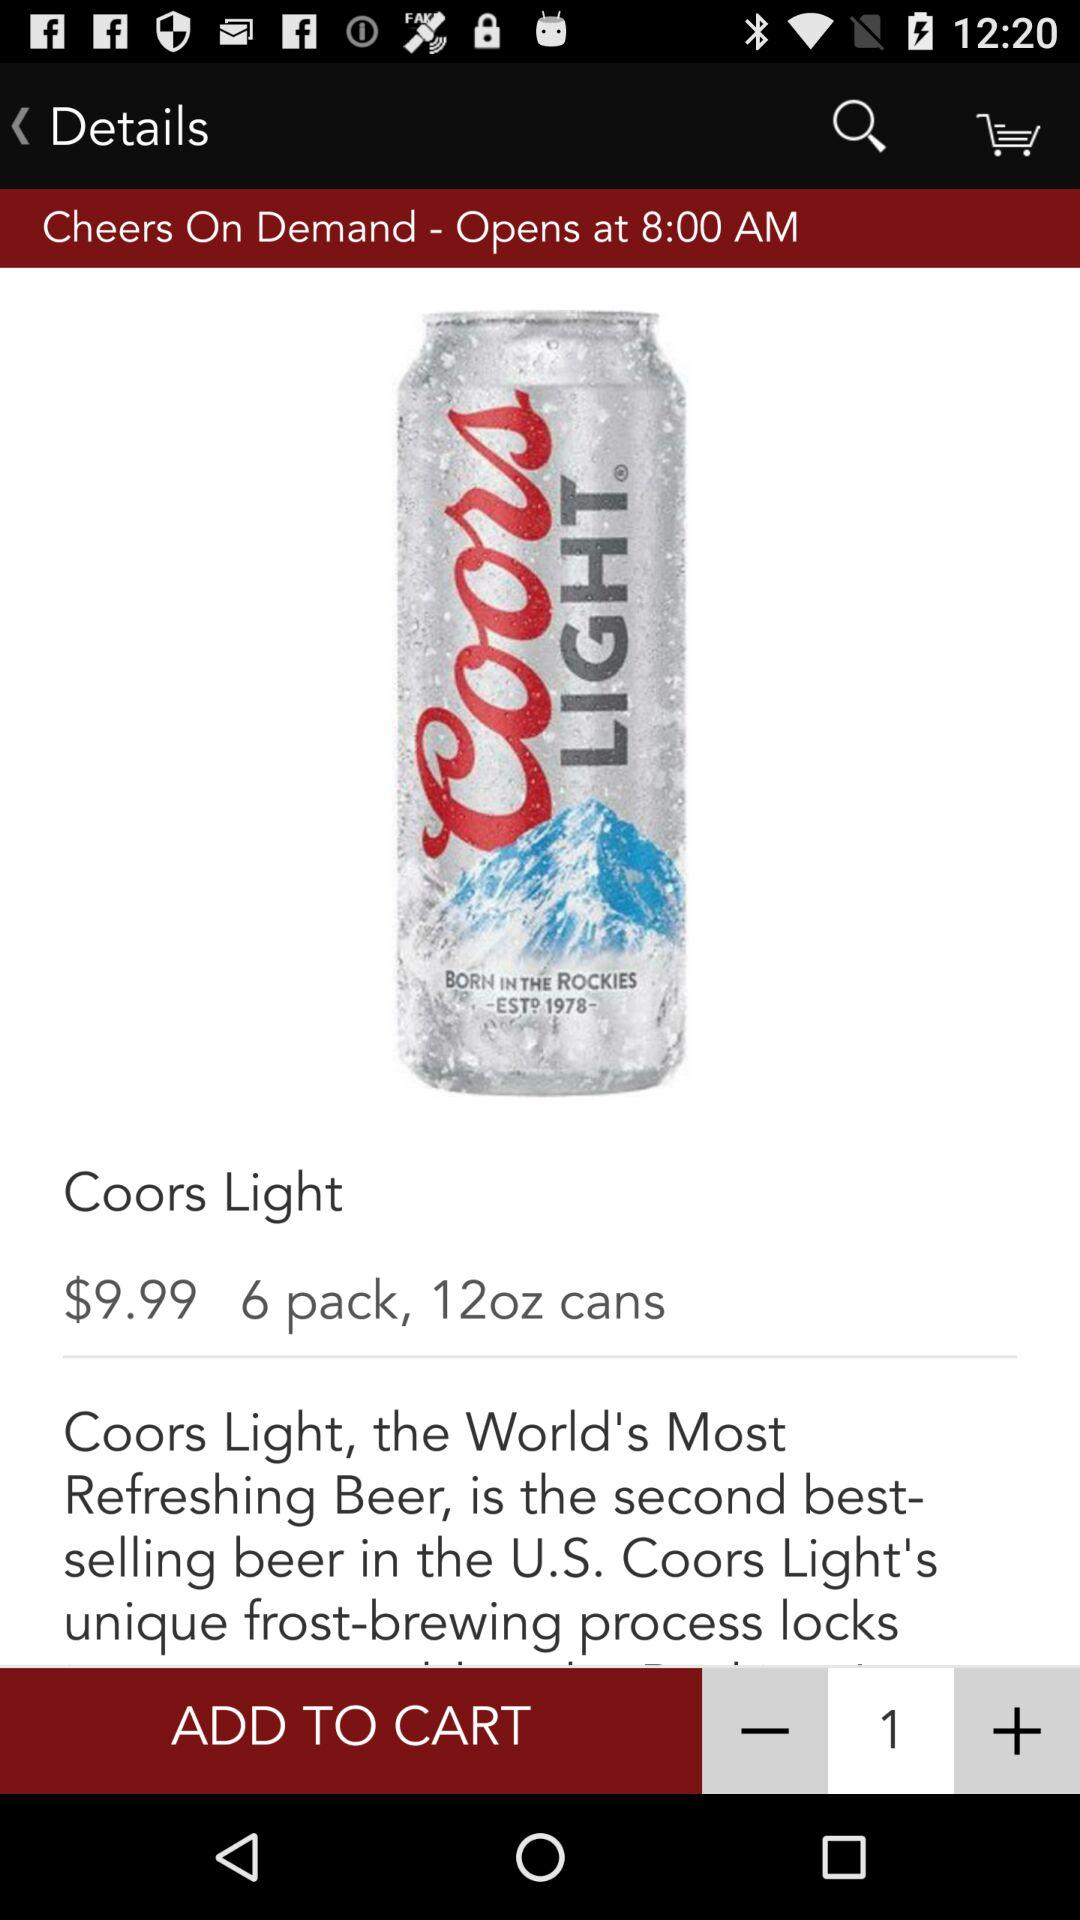How many cans of Coors Light are in a six pack?
Answer the question using a single word or phrase. 6 